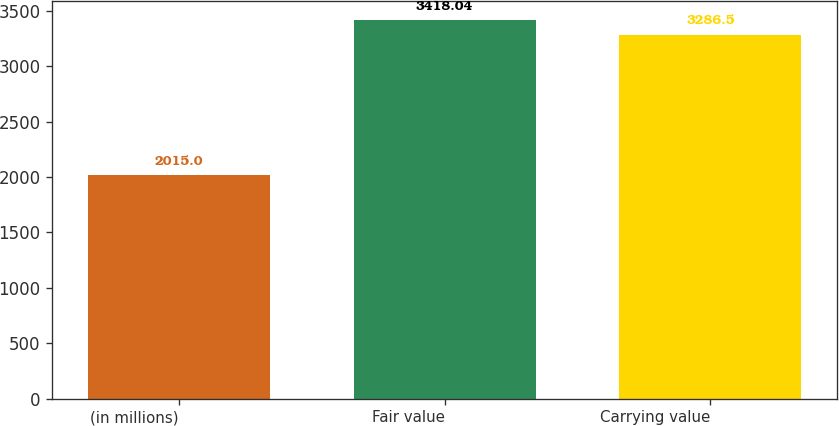Convert chart. <chart><loc_0><loc_0><loc_500><loc_500><bar_chart><fcel>(in millions)<fcel>Fair value<fcel>Carrying value<nl><fcel>2015<fcel>3418.04<fcel>3286.5<nl></chart> 